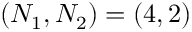<formula> <loc_0><loc_0><loc_500><loc_500>\left ( N _ { 1 } , N _ { 2 } \right ) = \left ( 4 , 2 \right )</formula> 